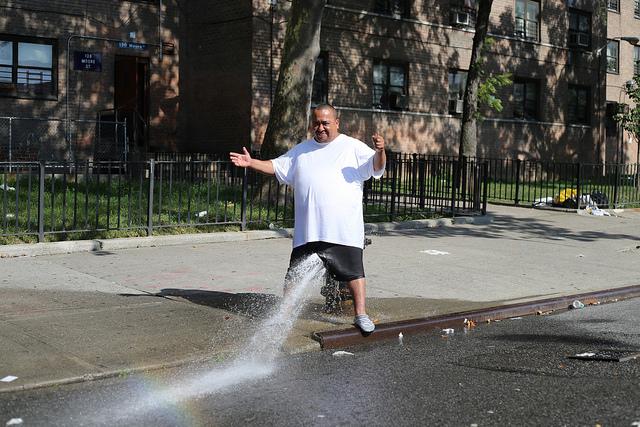What does it look like the man is doing based on where he is positioned?
Answer briefly. Peeing. Is there grass in the picture?
Short answer required. Yes. Is there a rainbow in the picture?
Answer briefly. Yes. 